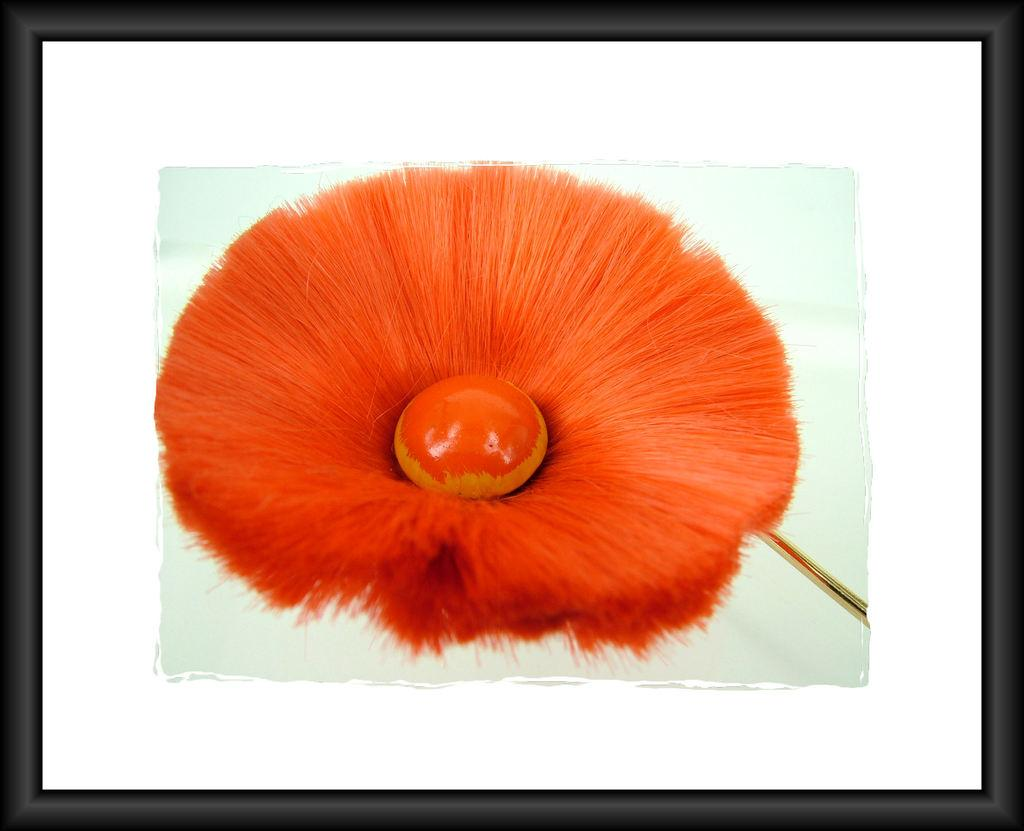What is the main subject of the image? The main subject of the image is a frame. What can be seen inside the frame in the image? There is a brush fossil visible inside the frame in the image. What shape is the system that the fossil is acting upon in the image? There is no system or act present in the image; it only features a frame with a brush fossil inside. 